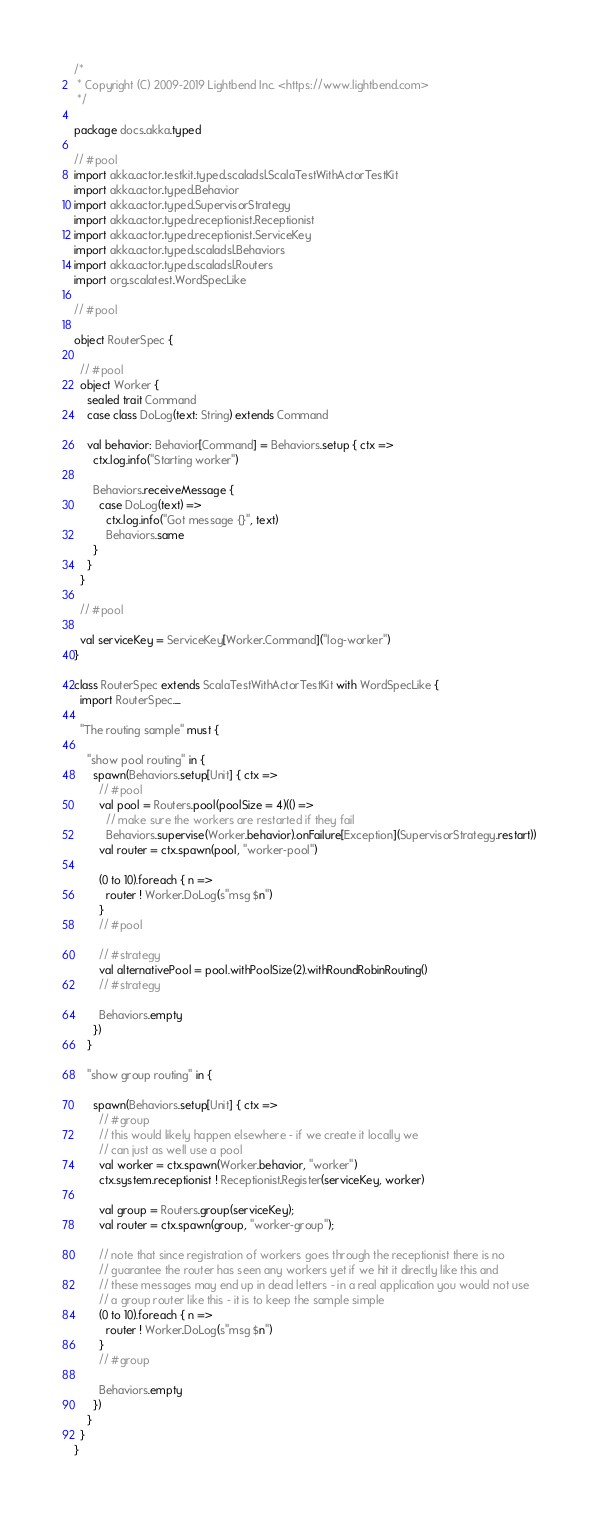Convert code to text. <code><loc_0><loc_0><loc_500><loc_500><_Scala_>/*
 * Copyright (C) 2009-2019 Lightbend Inc. <https://www.lightbend.com>
 */

package docs.akka.typed

// #pool
import akka.actor.testkit.typed.scaladsl.ScalaTestWithActorTestKit
import akka.actor.typed.Behavior
import akka.actor.typed.SupervisorStrategy
import akka.actor.typed.receptionist.Receptionist
import akka.actor.typed.receptionist.ServiceKey
import akka.actor.typed.scaladsl.Behaviors
import akka.actor.typed.scaladsl.Routers
import org.scalatest.WordSpecLike

// #pool

object RouterSpec {

  // #pool
  object Worker {
    sealed trait Command
    case class DoLog(text: String) extends Command

    val behavior: Behavior[Command] = Behaviors.setup { ctx =>
      ctx.log.info("Starting worker")

      Behaviors.receiveMessage {
        case DoLog(text) =>
          ctx.log.info("Got message {}", text)
          Behaviors.same
      }
    }
  }

  // #pool

  val serviceKey = ServiceKey[Worker.Command]("log-worker")
}

class RouterSpec extends ScalaTestWithActorTestKit with WordSpecLike {
  import RouterSpec._

  "The routing sample" must {

    "show pool routing" in {
      spawn(Behaviors.setup[Unit] { ctx =>
        // #pool
        val pool = Routers.pool(poolSize = 4)(() =>
          // make sure the workers are restarted if they fail
          Behaviors.supervise(Worker.behavior).onFailure[Exception](SupervisorStrategy.restart))
        val router = ctx.spawn(pool, "worker-pool")

        (0 to 10).foreach { n =>
          router ! Worker.DoLog(s"msg $n")
        }
        // #pool

        // #strategy
        val alternativePool = pool.withPoolSize(2).withRoundRobinRouting()
        // #strategy

        Behaviors.empty
      })
    }

    "show group routing" in {

      spawn(Behaviors.setup[Unit] { ctx =>
        // #group
        // this would likely happen elsewhere - if we create it locally we
        // can just as well use a pool
        val worker = ctx.spawn(Worker.behavior, "worker")
        ctx.system.receptionist ! Receptionist.Register(serviceKey, worker)

        val group = Routers.group(serviceKey);
        val router = ctx.spawn(group, "worker-group");

        // note that since registration of workers goes through the receptionist there is no
        // guarantee the router has seen any workers yet if we hit it directly like this and
        // these messages may end up in dead letters - in a real application you would not use
        // a group router like this - it is to keep the sample simple
        (0 to 10).foreach { n =>
          router ! Worker.DoLog(s"msg $n")
        }
        // #group

        Behaviors.empty
      })
    }
  }
}
</code> 